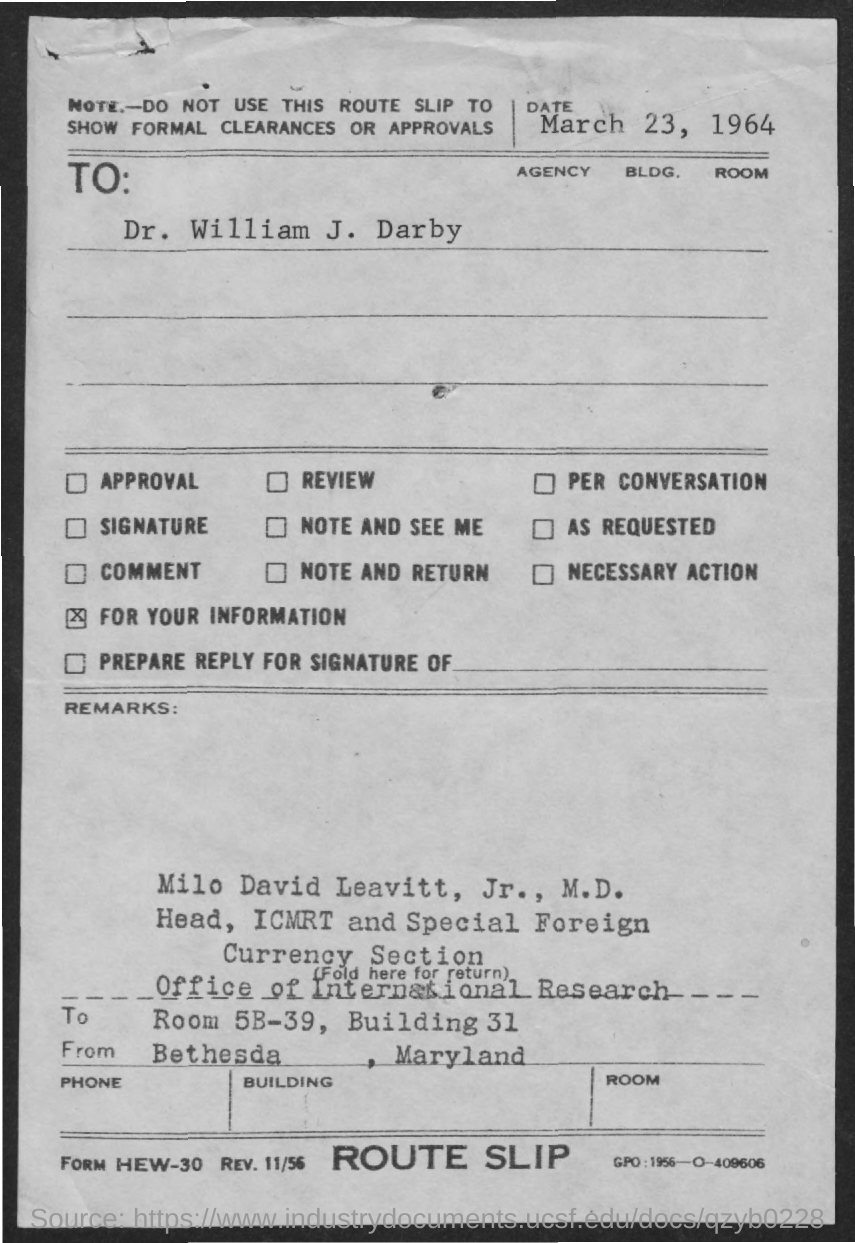Specify some key components in this picture. The date mentioned in the document is March 23, 1964. Milo David Leavitt, Jr., M.D., is the head of the ICMRT and the Special Foreign Currency Section. The user asks, "What is the building number?" The user then provides the numerical value of "31. The room number is 5B-39. 